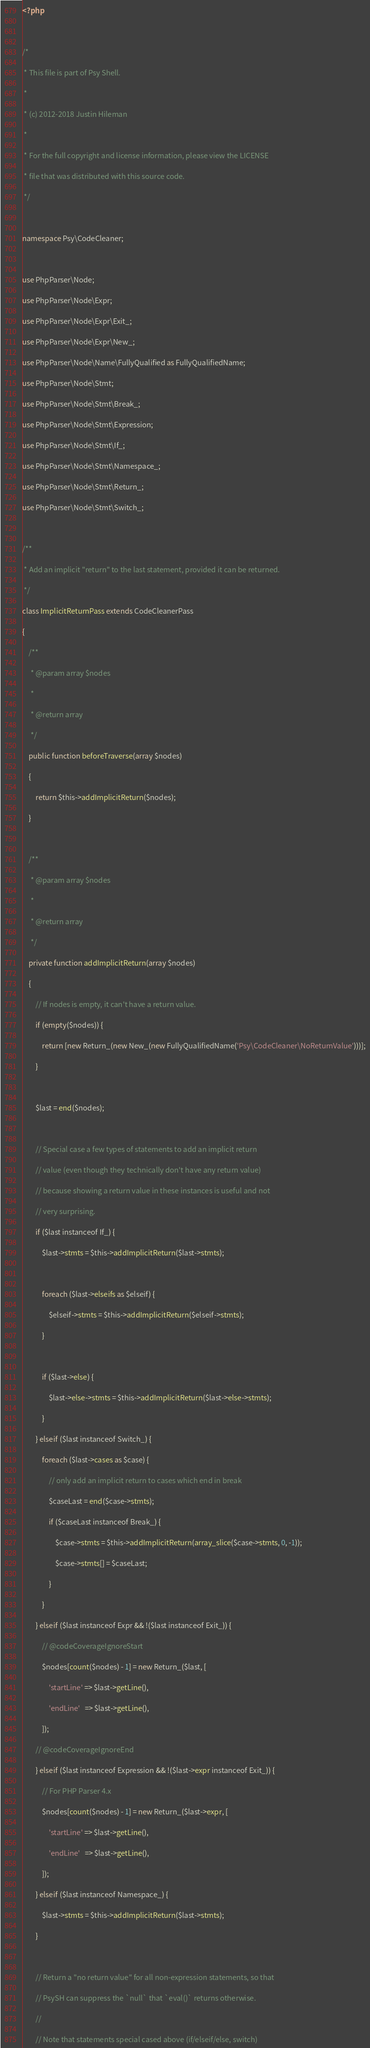Convert code to text. <code><loc_0><loc_0><loc_500><loc_500><_PHP_><?php

/*
 * This file is part of Psy Shell.
 *
 * (c) 2012-2018 Justin Hileman
 *
 * For the full copyright and license information, please view the LICENSE
 * file that was distributed with this source code.
 */

namespace Psy\CodeCleaner;

use PhpParser\Node;
use PhpParser\Node\Expr;
use PhpParser\Node\Expr\Exit_;
use PhpParser\Node\Expr\New_;
use PhpParser\Node\Name\FullyQualified as FullyQualifiedName;
use PhpParser\Node\Stmt;
use PhpParser\Node\Stmt\Break_;
use PhpParser\Node\Stmt\Expression;
use PhpParser\Node\Stmt\If_;
use PhpParser\Node\Stmt\Namespace_;
use PhpParser\Node\Stmt\Return_;
use PhpParser\Node\Stmt\Switch_;

/**
 * Add an implicit "return" to the last statement, provided it can be returned.
 */
class ImplicitReturnPass extends CodeCleanerPass
{
    /**
     * @param array $nodes
     *
     * @return array
     */
    public function beforeTraverse(array $nodes)
    {
        return $this->addImplicitReturn($nodes);
    }

    /**
     * @param array $nodes
     *
     * @return array
     */
    private function addImplicitReturn(array $nodes)
    {
        // If nodes is empty, it can't have a return value.
        if (empty($nodes)) {
            return [new Return_(new New_(new FullyQualifiedName('Psy\CodeCleaner\NoReturnValue')))];
        }

        $last = end($nodes);

        // Special case a few types of statements to add an implicit return
        // value (even though they technically don't have any return value)
        // because showing a return value in these instances is useful and not
        // very surprising.
        if ($last instanceof If_) {
            $last->stmts = $this->addImplicitReturn($last->stmts);

            foreach ($last->elseifs as $elseif) {
                $elseif->stmts = $this->addImplicitReturn($elseif->stmts);
            }

            if ($last->else) {
                $last->else->stmts = $this->addImplicitReturn($last->else->stmts);
            }
        } elseif ($last instanceof Switch_) {
            foreach ($last->cases as $case) {
                // only add an implicit return to cases which end in break
                $caseLast = end($case->stmts);
                if ($caseLast instanceof Break_) {
                    $case->stmts = $this->addImplicitReturn(array_slice($case->stmts, 0, -1));
                    $case->stmts[] = $caseLast;
                }
            }
        } elseif ($last instanceof Expr && !($last instanceof Exit_)) {
            // @codeCoverageIgnoreStart
            $nodes[count($nodes) - 1] = new Return_($last, [
                'startLine' => $last->getLine(),
                'endLine'   => $last->getLine(),
            ]);
        // @codeCoverageIgnoreEnd
        } elseif ($last instanceof Expression && !($last->expr instanceof Exit_)) {
            // For PHP Parser 4.x
            $nodes[count($nodes) - 1] = new Return_($last->expr, [
                'startLine' => $last->getLine(),
                'endLine'   => $last->getLine(),
            ]);
        } elseif ($last instanceof Namespace_) {
            $last->stmts = $this->addImplicitReturn($last->stmts);
        }

        // Return a "no return value" for all non-expression statements, so that
        // PsySH can suppress the `null` that `eval()` returns otherwise.
        //
        // Note that statements special cased above (if/elseif/else, switch)</code> 